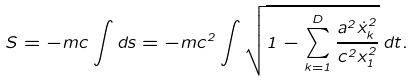Convert formula to latex. <formula><loc_0><loc_0><loc_500><loc_500>S = - m c \int d s = - m c ^ { 2 } \int \sqrt { 1 - \sum _ { k = 1 } ^ { D } \frac { a ^ { 2 } \dot { x } _ { k } ^ { 2 } } { c ^ { 2 } x _ { 1 } ^ { 2 } } } \, d t .</formula> 